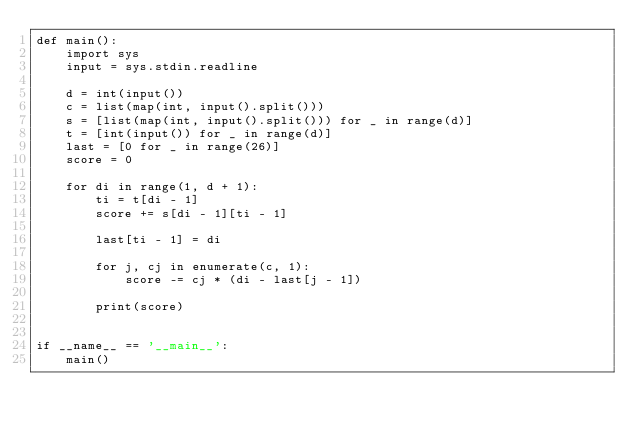Convert code to text. <code><loc_0><loc_0><loc_500><loc_500><_Python_>def main():
    import sys
    input = sys.stdin.readline

    d = int(input())
    c = list(map(int, input().split()))
    s = [list(map(int, input().split())) for _ in range(d)]
    t = [int(input()) for _ in range(d)]
    last = [0 for _ in range(26)]
    score = 0

    for di in range(1, d + 1):
        ti = t[di - 1]
        score += s[di - 1][ti - 1]

        last[ti - 1] = di

        for j, cj in enumerate(c, 1):
            score -= cj * (di - last[j - 1])

        print(score)


if __name__ == '__main__':
    main()</code> 